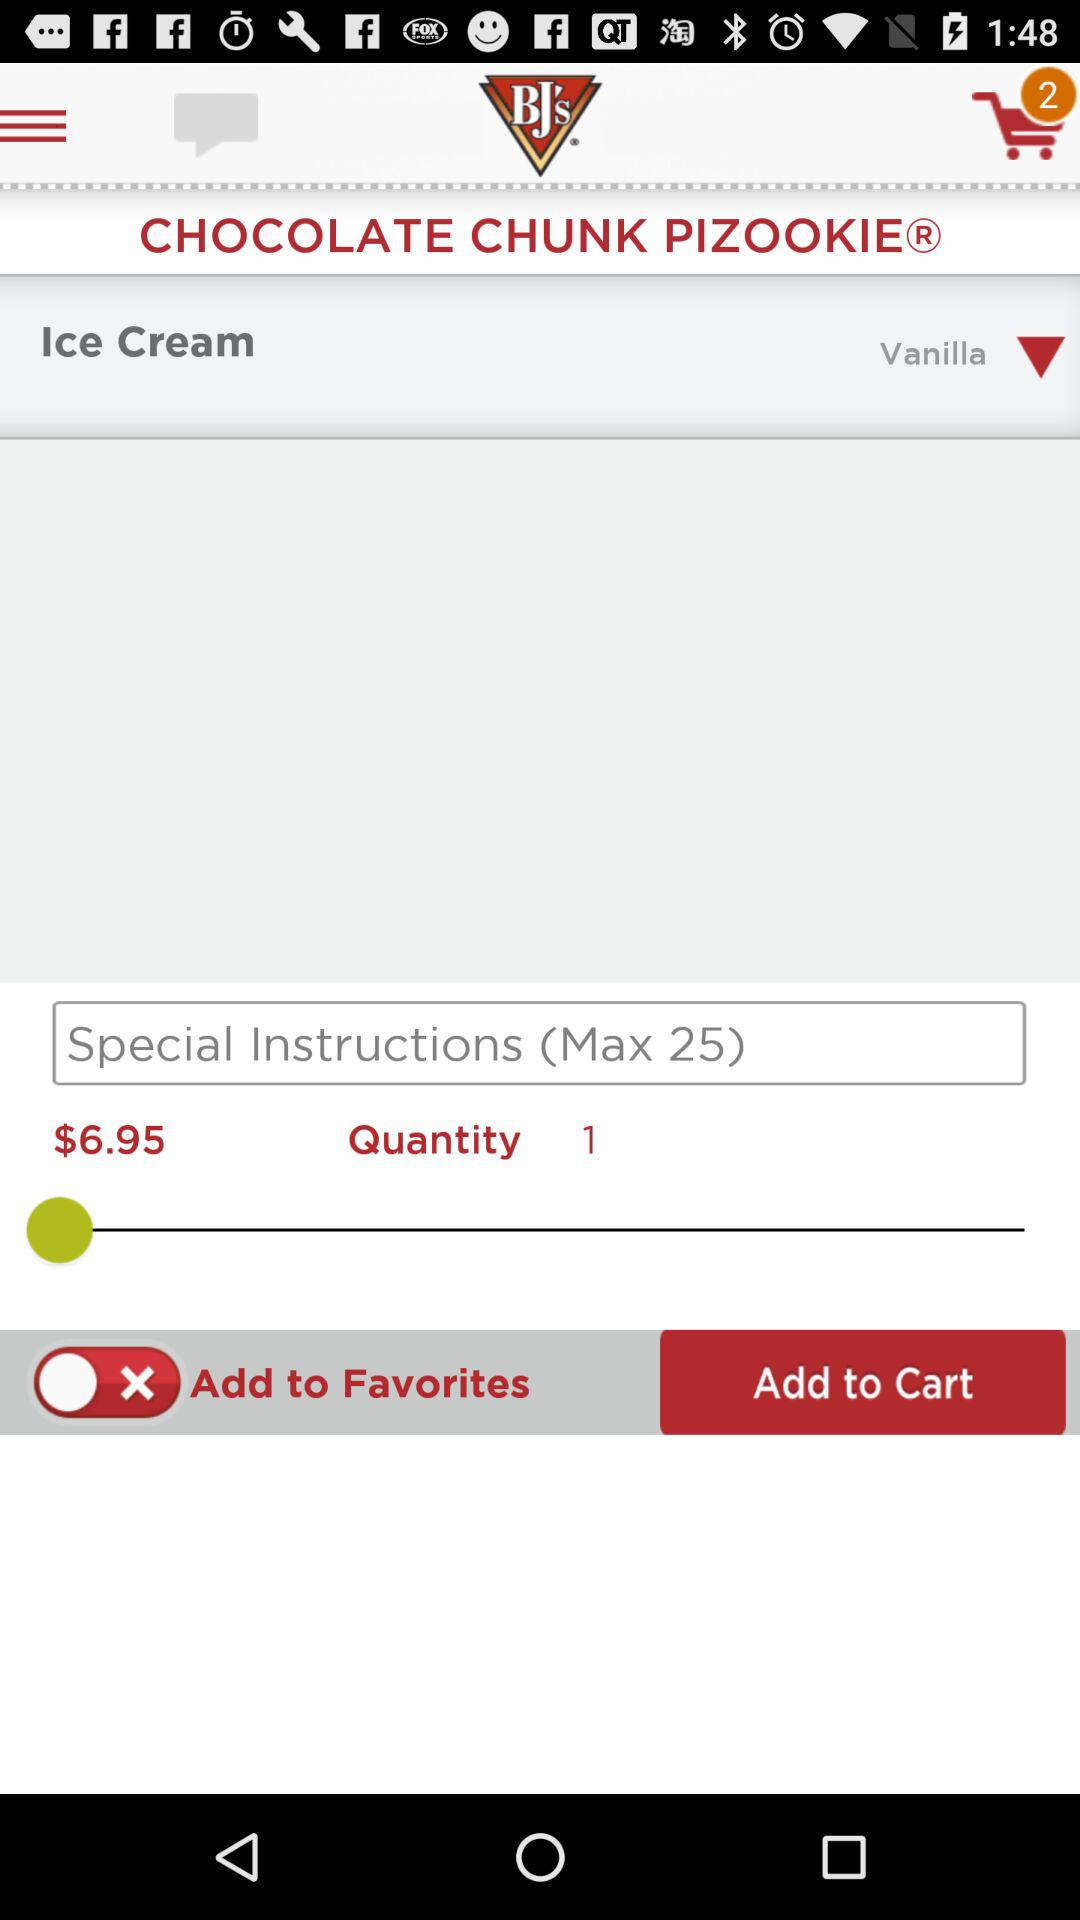Which flavor is selected for "Ice Cream"? The selected flavor is "Vanilla". 